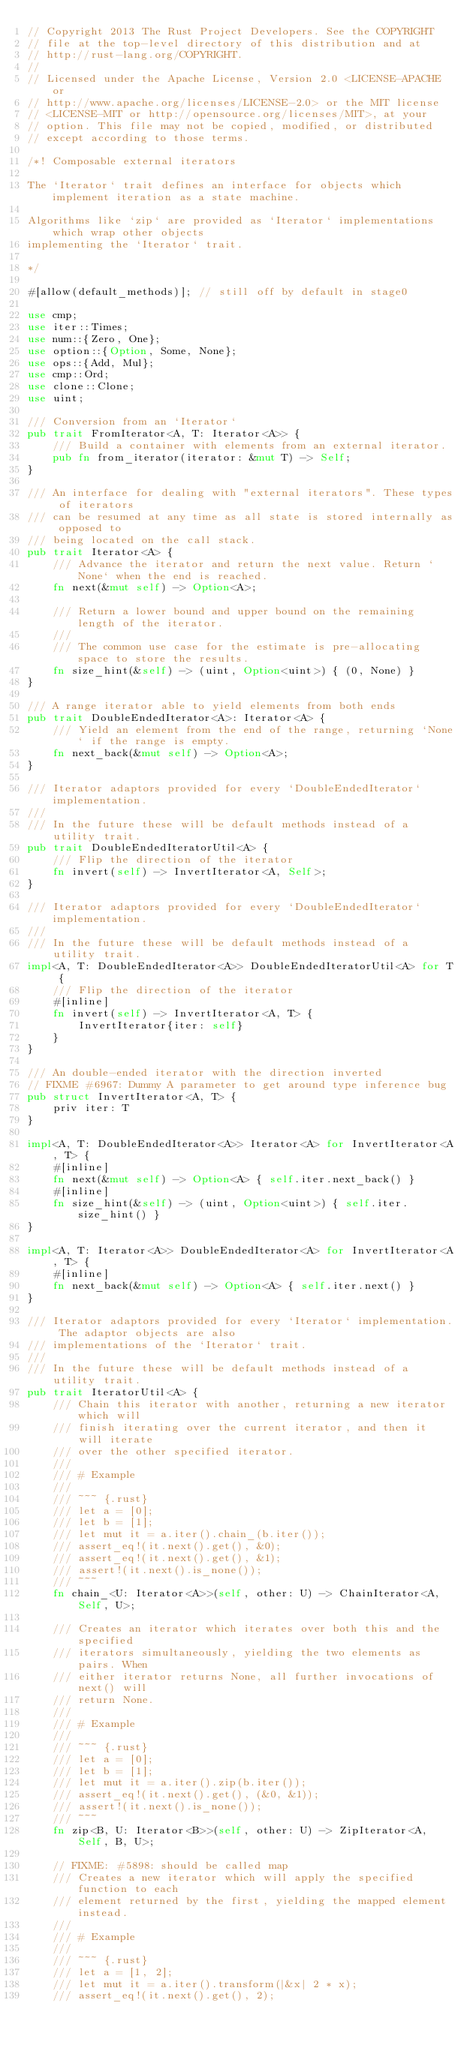<code> <loc_0><loc_0><loc_500><loc_500><_Rust_>// Copyright 2013 The Rust Project Developers. See the COPYRIGHT
// file at the top-level directory of this distribution and at
// http://rust-lang.org/COPYRIGHT.
//
// Licensed under the Apache License, Version 2.0 <LICENSE-APACHE or
// http://www.apache.org/licenses/LICENSE-2.0> or the MIT license
// <LICENSE-MIT or http://opensource.org/licenses/MIT>, at your
// option. This file may not be copied, modified, or distributed
// except according to those terms.

/*! Composable external iterators

The `Iterator` trait defines an interface for objects which implement iteration as a state machine.

Algorithms like `zip` are provided as `Iterator` implementations which wrap other objects
implementing the `Iterator` trait.

*/

#[allow(default_methods)]; // still off by default in stage0

use cmp;
use iter::Times;
use num::{Zero, One};
use option::{Option, Some, None};
use ops::{Add, Mul};
use cmp::Ord;
use clone::Clone;
use uint;

/// Conversion from an `Iterator`
pub trait FromIterator<A, T: Iterator<A>> {
    /// Build a container with elements from an external iterator.
    pub fn from_iterator(iterator: &mut T) -> Self;
}

/// An interface for dealing with "external iterators". These types of iterators
/// can be resumed at any time as all state is stored internally as opposed to
/// being located on the call stack.
pub trait Iterator<A> {
    /// Advance the iterator and return the next value. Return `None` when the end is reached.
    fn next(&mut self) -> Option<A>;

    /// Return a lower bound and upper bound on the remaining length of the iterator.
    ///
    /// The common use case for the estimate is pre-allocating space to store the results.
    fn size_hint(&self) -> (uint, Option<uint>) { (0, None) }
}

/// A range iterator able to yield elements from both ends
pub trait DoubleEndedIterator<A>: Iterator<A> {
    /// Yield an element from the end of the range, returning `None` if the range is empty.
    fn next_back(&mut self) -> Option<A>;
}

/// Iterator adaptors provided for every `DoubleEndedIterator` implementation.
///
/// In the future these will be default methods instead of a utility trait.
pub trait DoubleEndedIteratorUtil<A> {
    /// Flip the direction of the iterator
    fn invert(self) -> InvertIterator<A, Self>;
}

/// Iterator adaptors provided for every `DoubleEndedIterator` implementation.
///
/// In the future these will be default methods instead of a utility trait.
impl<A, T: DoubleEndedIterator<A>> DoubleEndedIteratorUtil<A> for T {
    /// Flip the direction of the iterator
    #[inline]
    fn invert(self) -> InvertIterator<A, T> {
        InvertIterator{iter: self}
    }
}

/// An double-ended iterator with the direction inverted
// FIXME #6967: Dummy A parameter to get around type inference bug
pub struct InvertIterator<A, T> {
    priv iter: T
}

impl<A, T: DoubleEndedIterator<A>> Iterator<A> for InvertIterator<A, T> {
    #[inline]
    fn next(&mut self) -> Option<A> { self.iter.next_back() }
    #[inline]
    fn size_hint(&self) -> (uint, Option<uint>) { self.iter.size_hint() }
}

impl<A, T: Iterator<A>> DoubleEndedIterator<A> for InvertIterator<A, T> {
    #[inline]
    fn next_back(&mut self) -> Option<A> { self.iter.next() }
}

/// Iterator adaptors provided for every `Iterator` implementation. The adaptor objects are also
/// implementations of the `Iterator` trait.
///
/// In the future these will be default methods instead of a utility trait.
pub trait IteratorUtil<A> {
    /// Chain this iterator with another, returning a new iterator which will
    /// finish iterating over the current iterator, and then it will iterate
    /// over the other specified iterator.
    ///
    /// # Example
    ///
    /// ~~~ {.rust}
    /// let a = [0];
    /// let b = [1];
    /// let mut it = a.iter().chain_(b.iter());
    /// assert_eq!(it.next().get(), &0);
    /// assert_eq!(it.next().get(), &1);
    /// assert!(it.next().is_none());
    /// ~~~
    fn chain_<U: Iterator<A>>(self, other: U) -> ChainIterator<A, Self, U>;

    /// Creates an iterator which iterates over both this and the specified
    /// iterators simultaneously, yielding the two elements as pairs. When
    /// either iterator returns None, all further invocations of next() will
    /// return None.
    ///
    /// # Example
    ///
    /// ~~~ {.rust}
    /// let a = [0];
    /// let b = [1];
    /// let mut it = a.iter().zip(b.iter());
    /// assert_eq!(it.next().get(), (&0, &1));
    /// assert!(it.next().is_none());
    /// ~~~
    fn zip<B, U: Iterator<B>>(self, other: U) -> ZipIterator<A, Self, B, U>;

    // FIXME: #5898: should be called map
    /// Creates a new iterator which will apply the specified function to each
    /// element returned by the first, yielding the mapped element instead.
    ///
    /// # Example
    ///
    /// ~~~ {.rust}
    /// let a = [1, 2];
    /// let mut it = a.iter().transform(|&x| 2 * x);
    /// assert_eq!(it.next().get(), 2);</code> 